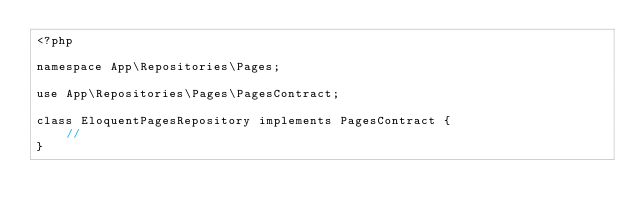<code> <loc_0><loc_0><loc_500><loc_500><_PHP_><?php

namespace App\Repositories\Pages;

use App\Repositories\Pages\PagesContract;

class EloquentPagesRepository implements PagesContract {
    //
}
</code> 